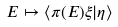<formula> <loc_0><loc_0><loc_500><loc_500>E \mapsto \langle \pi ( E ) \xi | \eta \rangle</formula> 